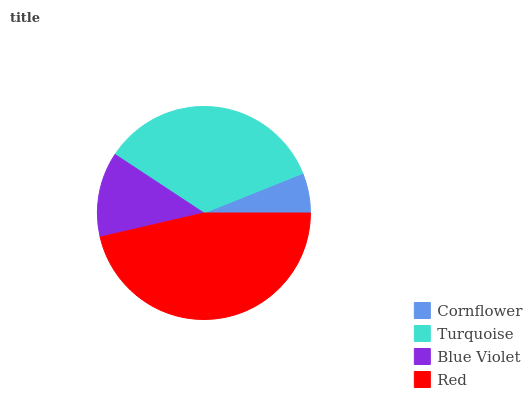Is Cornflower the minimum?
Answer yes or no. Yes. Is Red the maximum?
Answer yes or no. Yes. Is Turquoise the minimum?
Answer yes or no. No. Is Turquoise the maximum?
Answer yes or no. No. Is Turquoise greater than Cornflower?
Answer yes or no. Yes. Is Cornflower less than Turquoise?
Answer yes or no. Yes. Is Cornflower greater than Turquoise?
Answer yes or no. No. Is Turquoise less than Cornflower?
Answer yes or no. No. Is Turquoise the high median?
Answer yes or no. Yes. Is Blue Violet the low median?
Answer yes or no. Yes. Is Blue Violet the high median?
Answer yes or no. No. Is Red the low median?
Answer yes or no. No. 